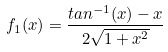Convert formula to latex. <formula><loc_0><loc_0><loc_500><loc_500>f _ { 1 } ( x ) = \frac { t a n ^ { - 1 } ( x ) - x } { 2 \sqrt { 1 + x ^ { 2 } } }</formula> 